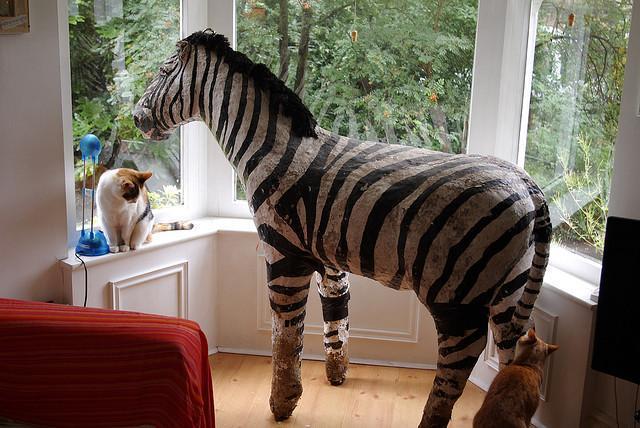How many cats are here?
Give a very brief answer. 2. How many cats are in the photo?
Give a very brief answer. 2. How many motorcycles have two helmets?
Give a very brief answer. 0. 